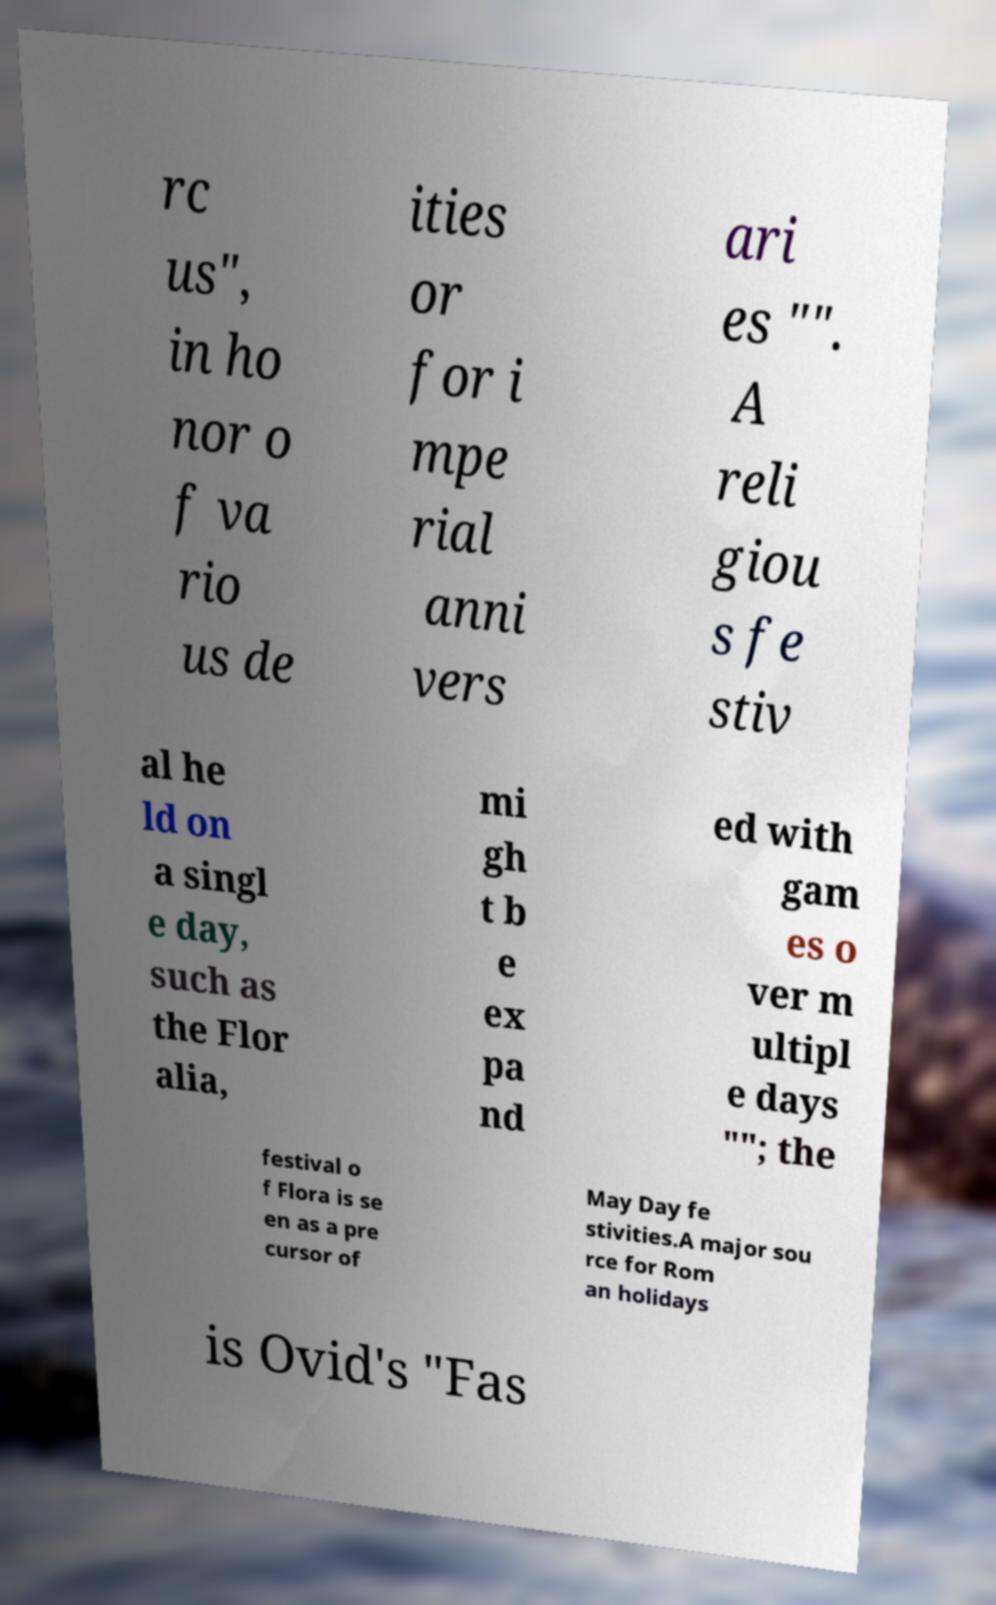Can you read and provide the text displayed in the image?This photo seems to have some interesting text. Can you extract and type it out for me? rc us", in ho nor o f va rio us de ities or for i mpe rial anni vers ari es "". A reli giou s fe stiv al he ld on a singl e day, such as the Flor alia, mi gh t b e ex pa nd ed with gam es o ver m ultipl e days ""; the festival o f Flora is se en as a pre cursor of May Day fe stivities.A major sou rce for Rom an holidays is Ovid's "Fas 